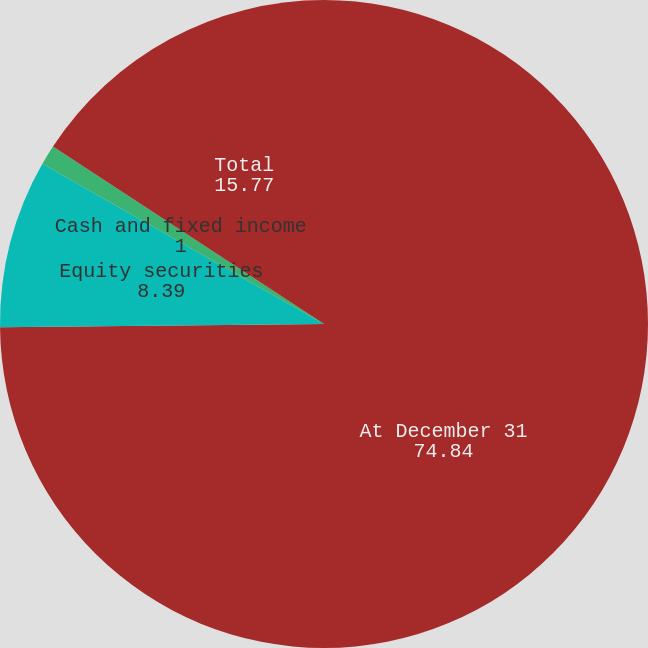<chart> <loc_0><loc_0><loc_500><loc_500><pie_chart><fcel>At December 31<fcel>Equity securities<fcel>Cash and fixed income<fcel>Total<nl><fcel>74.84%<fcel>8.39%<fcel>1.0%<fcel>15.77%<nl></chart> 